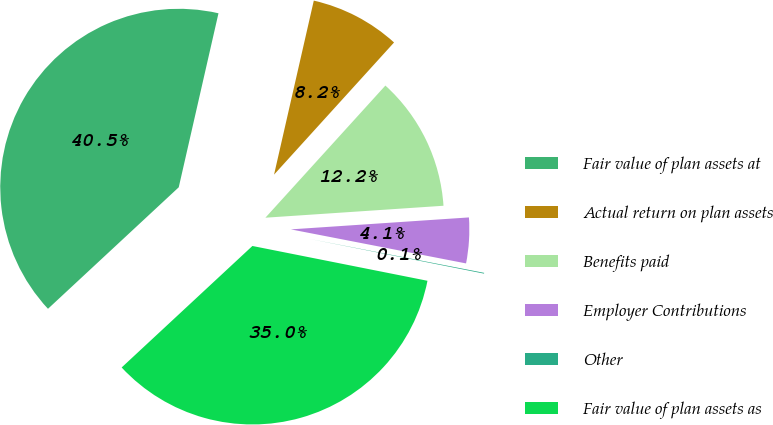<chart> <loc_0><loc_0><loc_500><loc_500><pie_chart><fcel>Fair value of plan assets at<fcel>Actual return on plan assets<fcel>Benefits paid<fcel>Employer Contributions<fcel>Other<fcel>Fair value of plan assets as<nl><fcel>40.49%<fcel>8.16%<fcel>12.2%<fcel>4.12%<fcel>0.07%<fcel>34.96%<nl></chart> 